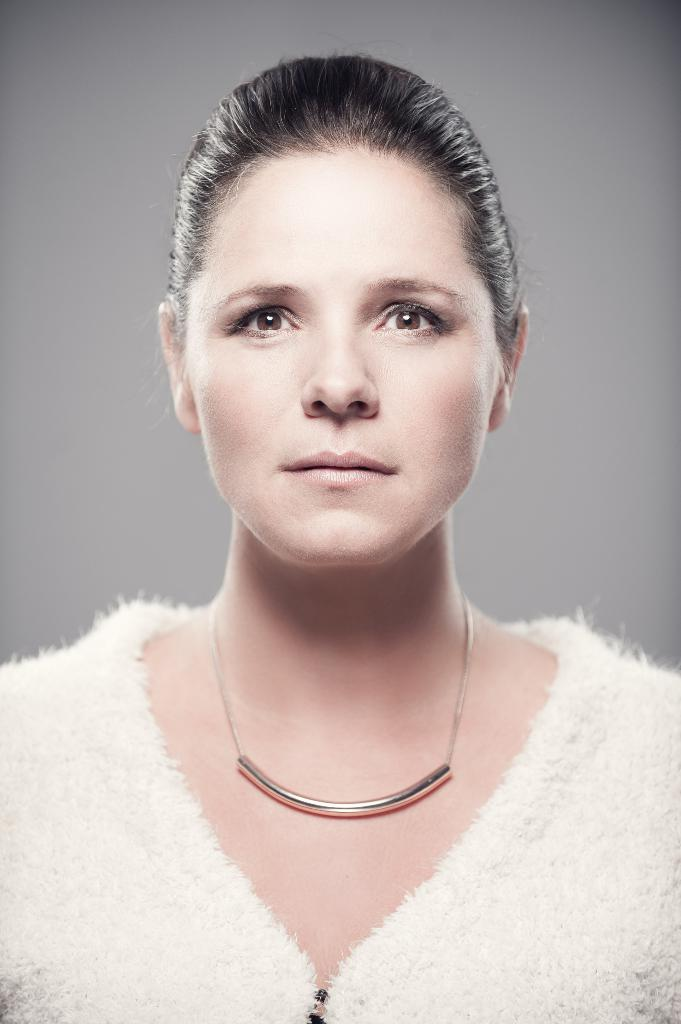What is the main subject of the image? There is a woman standing in the image. What is the woman wearing in the image? The woman is wearing a white dress and a necklace. What can be seen in the background of the image? There is an ash-colored surface in the background of the image. What type of polish is the woman applying to her nails in the image? There is no indication in the image that the woman is applying polish to her nails, and therefore no such activity can be observed. 